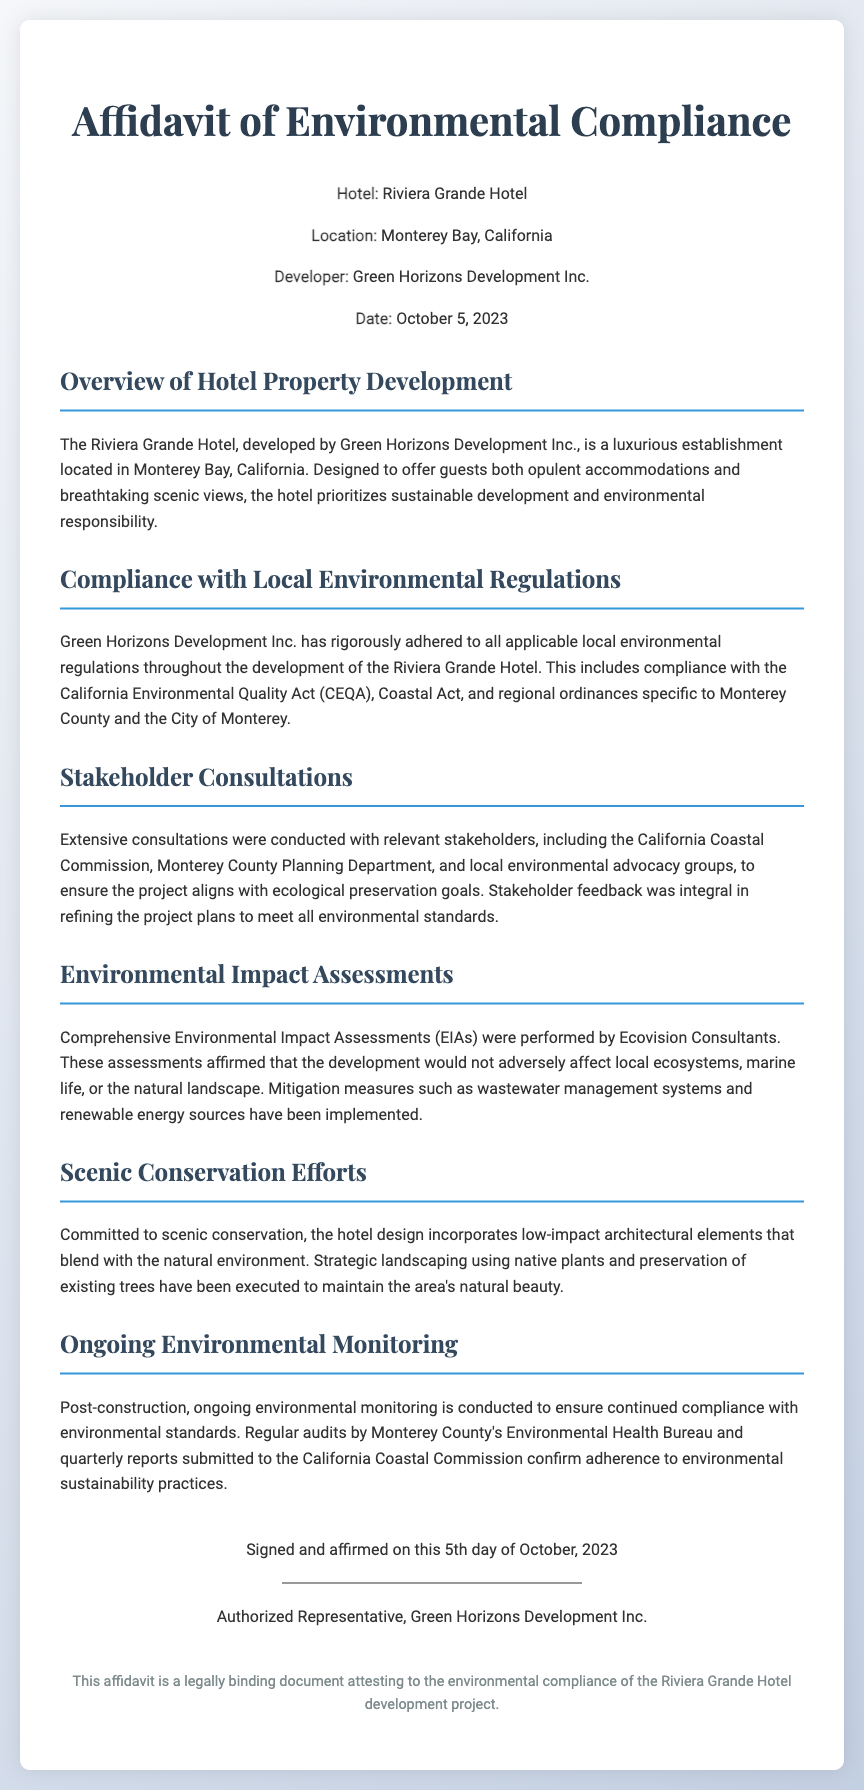what is the hotel name? The hotel name is explicitly mentioned in the header of the document as Riviera Grande Hotel.
Answer: Riviera Grande Hotel who is the developer? The developer is listed in the document under the hotel information section as Green Horizons Development Inc.
Answer: Green Horizons Development Inc what is the location of the hotel? The specific location of the hotel is detailed in the document as Monterey Bay, California.
Answer: Monterey Bay, California what date was the affidavit signed? The signing date of the affidavit is provided in the document as October 5, 2023.
Answer: October 5, 2023 which act does the project comply with? The document states that the project complies with the California Environmental Quality Act (CEQA).
Answer: California Environmental Quality Act (CEQA) what kind of consultations were conducted? The document describes the consultations as extensive and involving relevant stakeholders such as the California Coastal Commission.
Answer: Extensive consultations what measures were implemented for environmental impact? The document mentions that mitigation measures like wastewater management systems and renewable energy sources have been implemented.
Answer: Wastewater management systems and renewable energy sources what type of assessments were performed? The document indicates that Comprehensive Environmental Impact Assessments (EIAs) were performed by Ecovision Consultants.
Answer: Comprehensive Environmental Impact Assessments (EIAs) how is ongoing compliance verified? The document explains that ongoing environmental monitoring and regular audits are conducted to ensure continued compliance.
Answer: Ongoing environmental monitoring and regular audits 